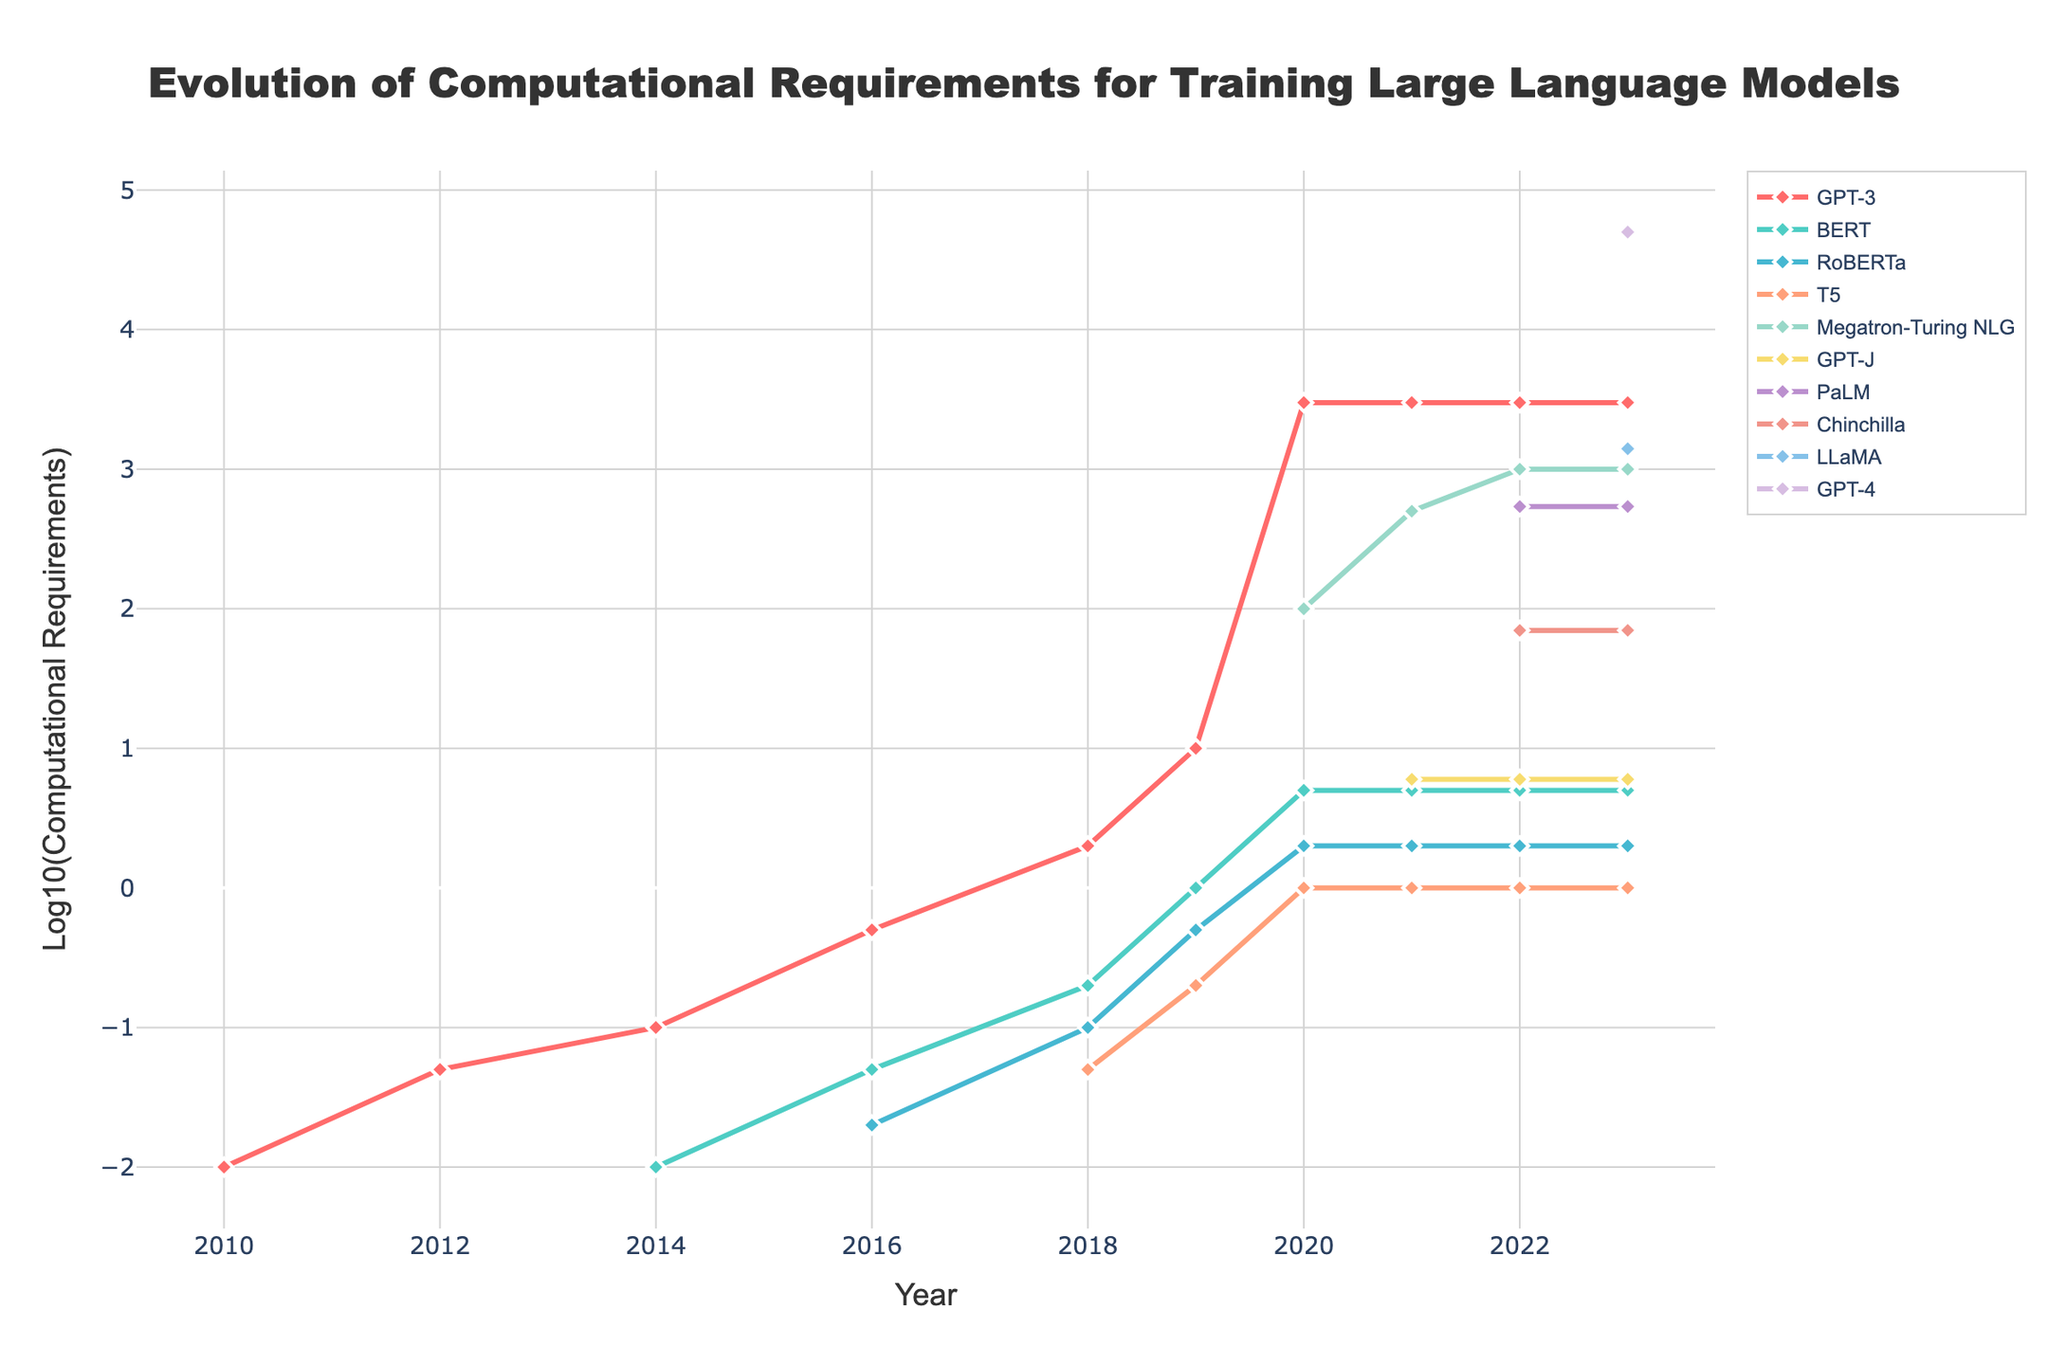What trend is observed for GPT-3 from 2020 to 2023? From 2020 to 2023, the computational requirements for GPT-3 remain constant at a log scale value, indicating that there is no visible change in the computational requirements for GPT-3 during this period.
Answer: No change Which model had the highest computational requirement in 2023? In 2023, GPT-4 had the highest line and marker position on the y-axis (log scale), indicating the highest computational requirement among all models.
Answer: GPT-4 How much did the computational requirements for Megatron-Turing NLG increase from 2020 to 2022? Megatron-Turing NLG increased from 100 in 2020 to 1000 in 2022. To calculate the increase, we subtract the initial value from the final value: 1000 - 100 = 900.
Answer: 900 Which model experienced a sudden increase in computational requirements in 2022? Chinchilla had a visible jump in its log scale value in 2022, indicating a sudden increase in computational requirements.
Answer: Chinchilla Compare the computational requirements of BERT and T5 in 2019. Which one was higher? In 2019, BERT had a log scale value corresponding to its computational requirements that are higher than that of T5, as indicated by the position of BERT's marker being above T5's marker on the y-axis.
Answer: BERT What was the computational requirement for PaLM in 2022? The marker for PaLM in 2022 corresponds to the log scale value of approximately 540.
Answer: 540 Which model shows a generally constant computational requirement from 2020 to 2023? GPT-3 shows a constant computational requirement from 2020 to 2023, as indicated by the straight horizontal line on the log scale.
Answer: GPT-3 Was LLaMA developed before or after 2022? LLaMA appears on the plot in 2023, indicating it was developed after 2022.
Answer: After 2022 Which models have visible log-scale values close to each other in 2021? In 2021, BERT and RoBERTa have closely positioned markers on the log-scale, indicating similar computational requirements.
Answer: BERT and RoBERTa 